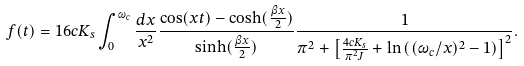<formula> <loc_0><loc_0><loc_500><loc_500>f ( t ) = 1 6 c K _ { s } \int _ { 0 } ^ { \omega _ { c } } \frac { d x } { x ^ { 2 } } \frac { \cos ( x t ) - \cosh ( \frac { \beta x } { 2 } ) } { \sinh ( \frac { \beta x } { 2 } ) } \frac { 1 } { \pi ^ { 2 } + \left [ \frac { 4 c K _ { s } } { \pi ^ { 2 } J } + \ln \left ( ( \omega _ { c } / x ) ^ { 2 } - 1 \right ) \right ] ^ { 2 } } .</formula> 